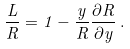<formula> <loc_0><loc_0><loc_500><loc_500>\frac { L } { R } = 1 - \frac { y } { R } \frac { \partial R } { \partial y } \, .</formula> 